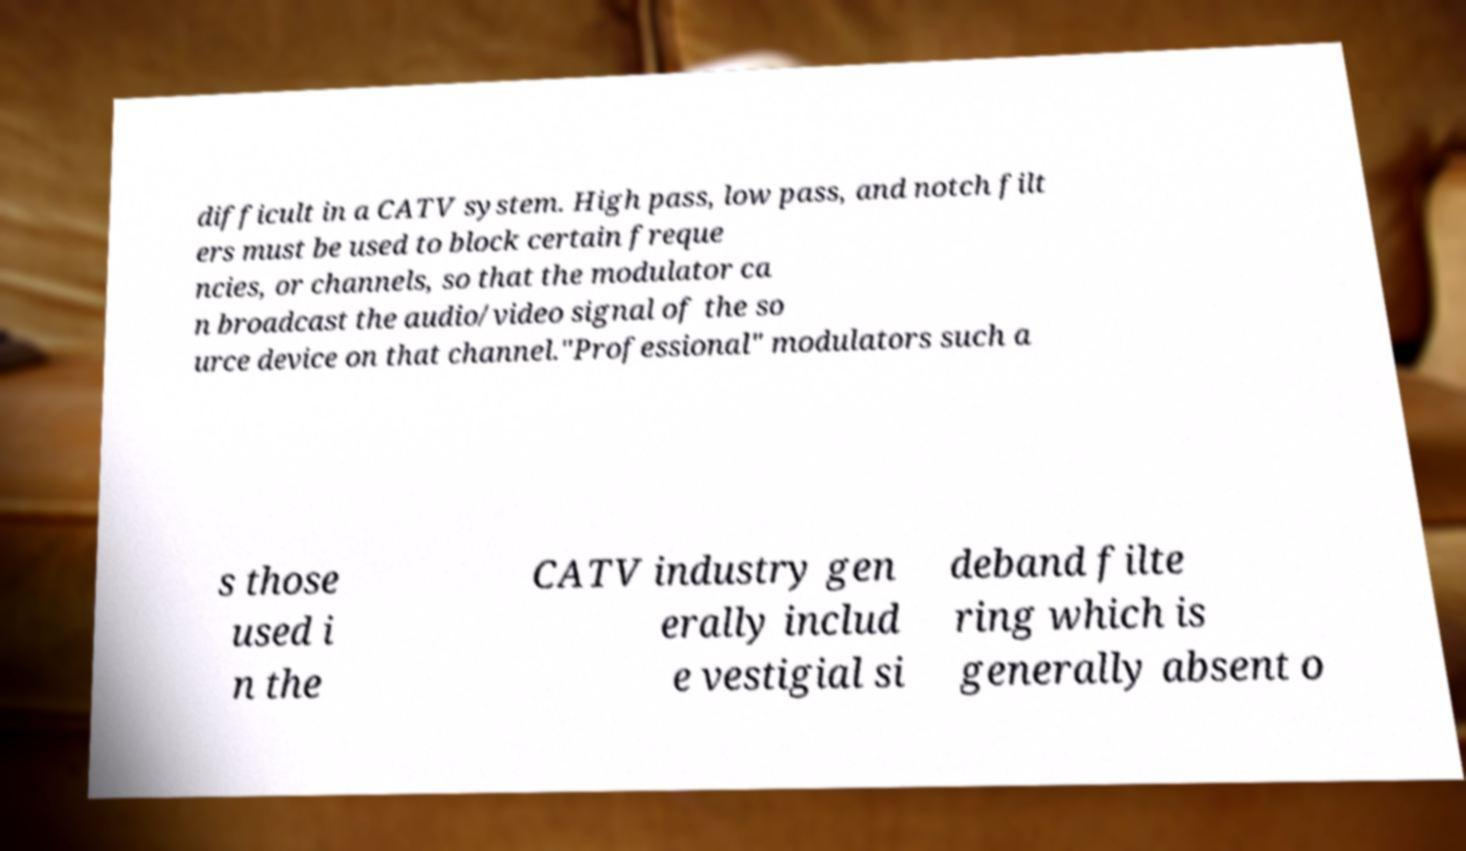Could you assist in decoding the text presented in this image and type it out clearly? difficult in a CATV system. High pass, low pass, and notch filt ers must be used to block certain freque ncies, or channels, so that the modulator ca n broadcast the audio/video signal of the so urce device on that channel."Professional" modulators such a s those used i n the CATV industry gen erally includ e vestigial si deband filte ring which is generally absent o 